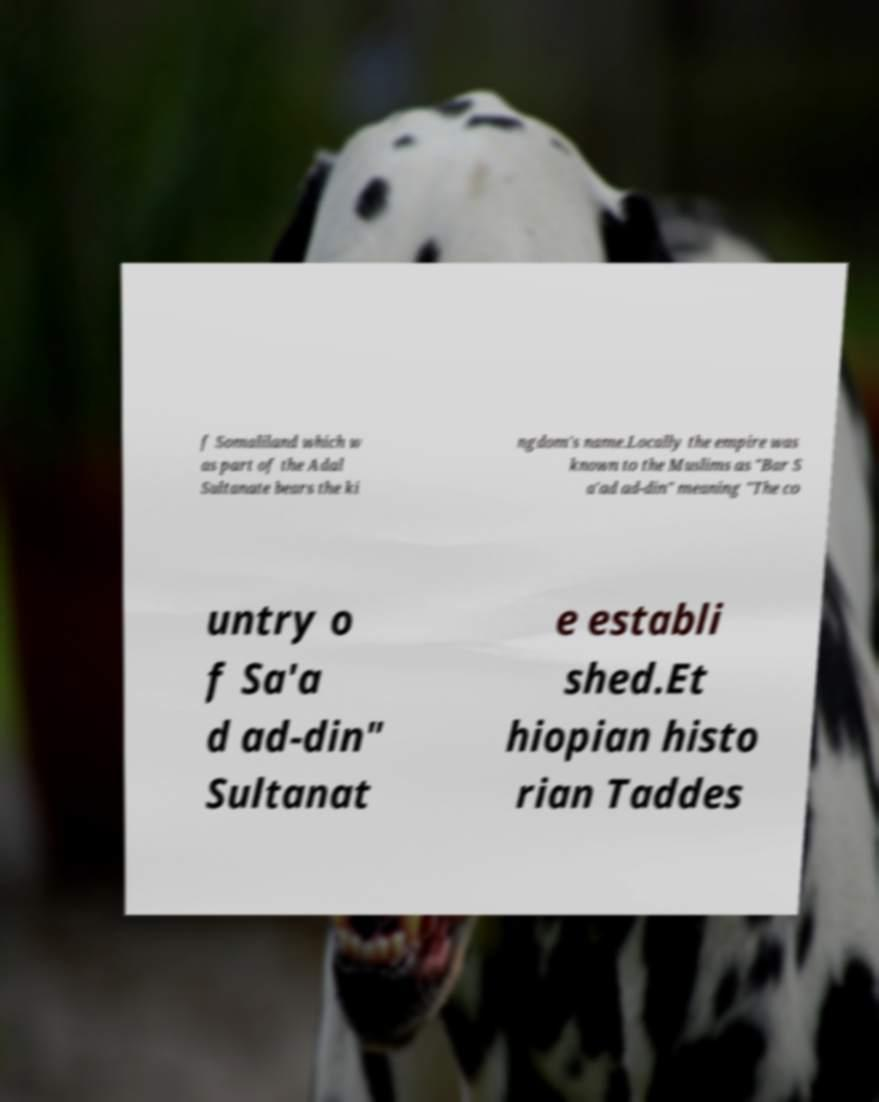What messages or text are displayed in this image? I need them in a readable, typed format. f Somaliland which w as part of the Adal Sultanate bears the ki ngdom's name.Locally the empire was known to the Muslims as "Bar S a'ad ad-din" meaning "The co untry o f Sa'a d ad-din" Sultanat e establi shed.Et hiopian histo rian Taddes 